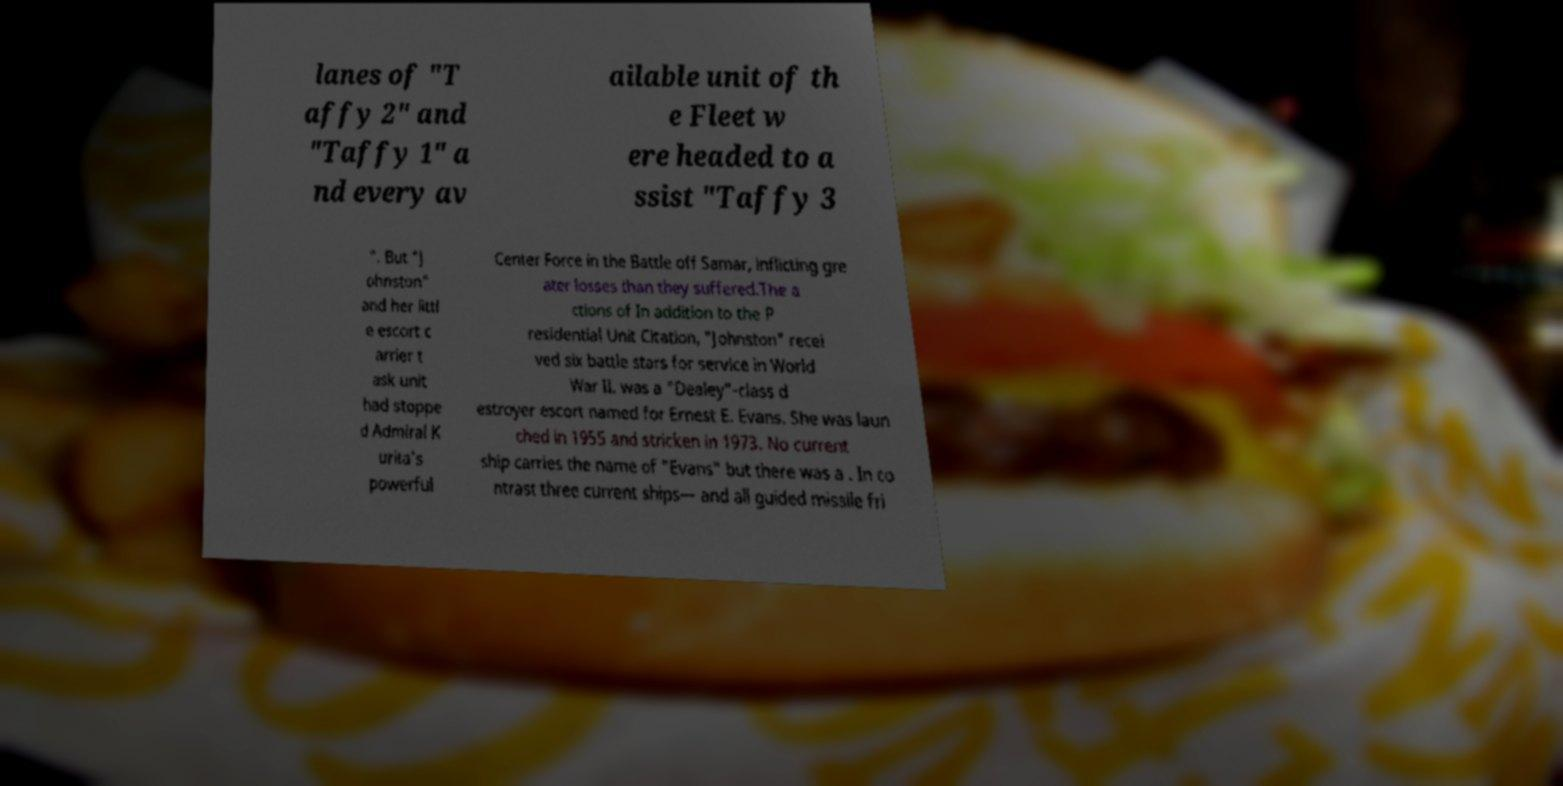There's text embedded in this image that I need extracted. Can you transcribe it verbatim? lanes of "T affy 2" and "Taffy 1" a nd every av ailable unit of th e Fleet w ere headed to a ssist "Taffy 3 ". But "J ohnston" and her littl e escort c arrier t ask unit had stoppe d Admiral K urita's powerful Center Force in the Battle off Samar, inflicting gre ater losses than they suffered.The a ctions of In addition to the P residential Unit Citation, "Johnston" recei ved six battle stars for service in World War II. was a "Dealey"-class d estroyer escort named for Ernest E. Evans. She was laun ched in 1955 and stricken in 1973. No current ship carries the name of "Evans" but there was a . In co ntrast three current ships— and all guided missile fri 